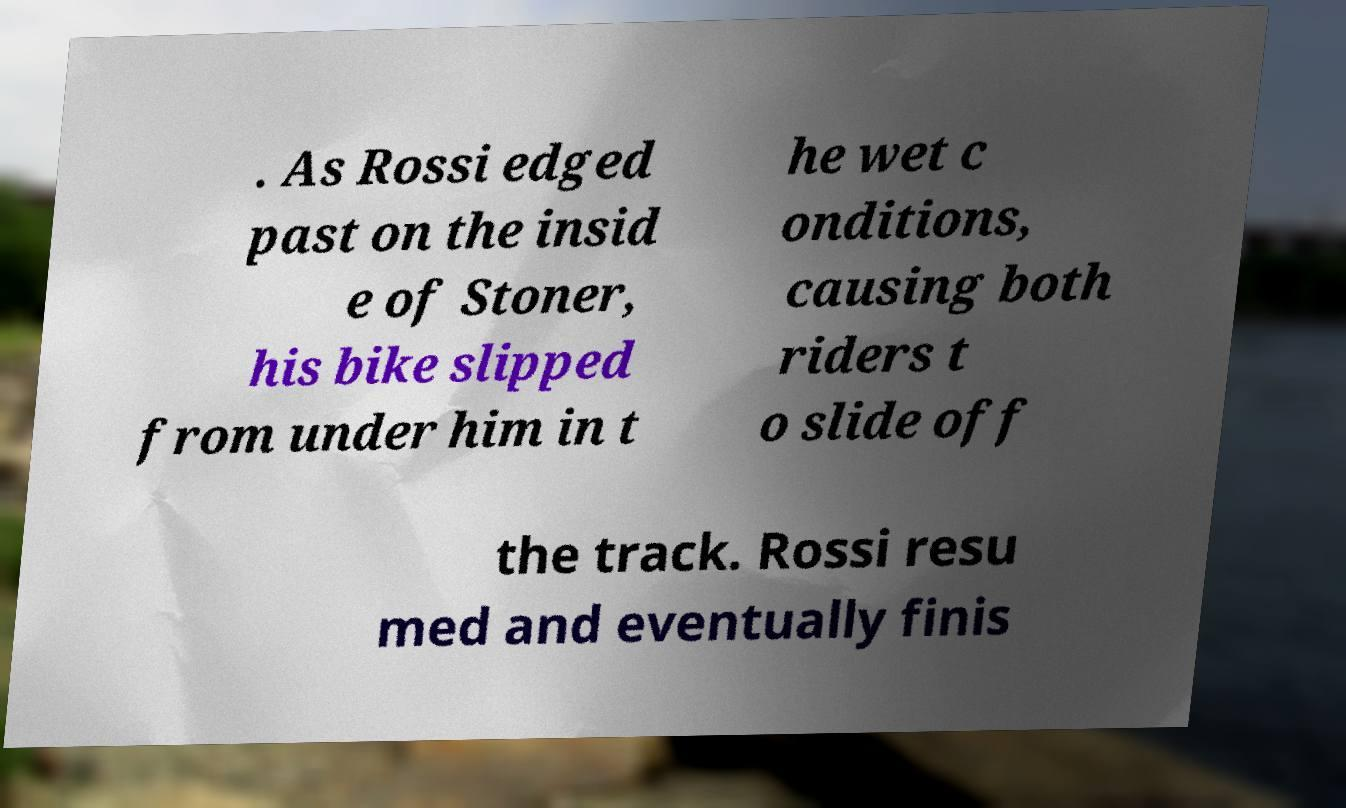Could you extract and type out the text from this image? . As Rossi edged past on the insid e of Stoner, his bike slipped from under him in t he wet c onditions, causing both riders t o slide off the track. Rossi resu med and eventually finis 